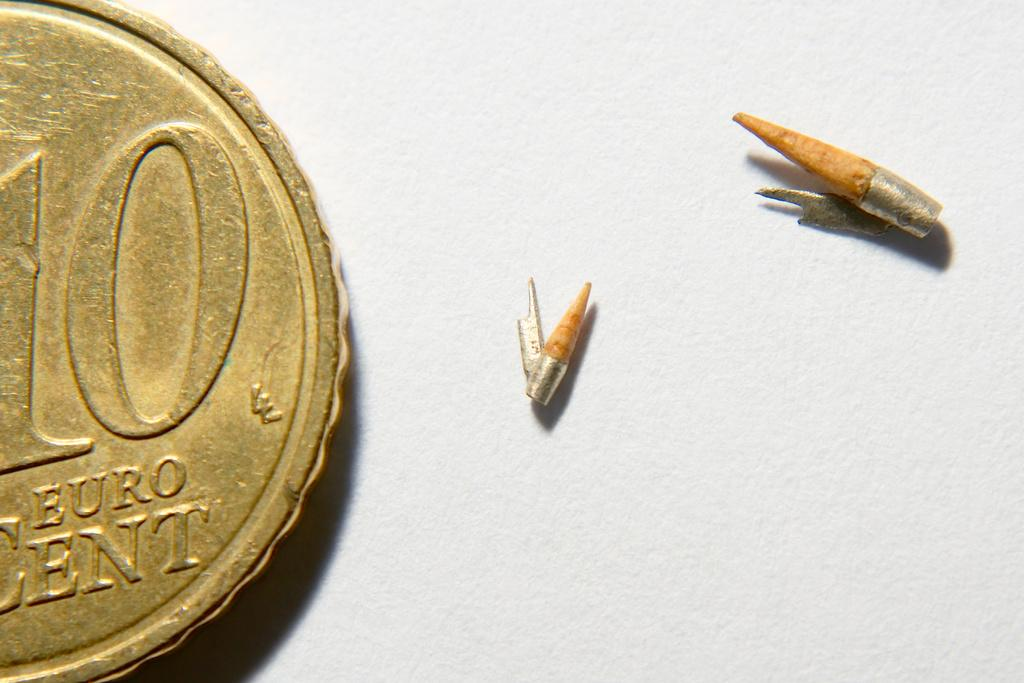<image>
Present a compact description of the photo's key features. Gold coin showing 10 Euro cents next to two small objects. 